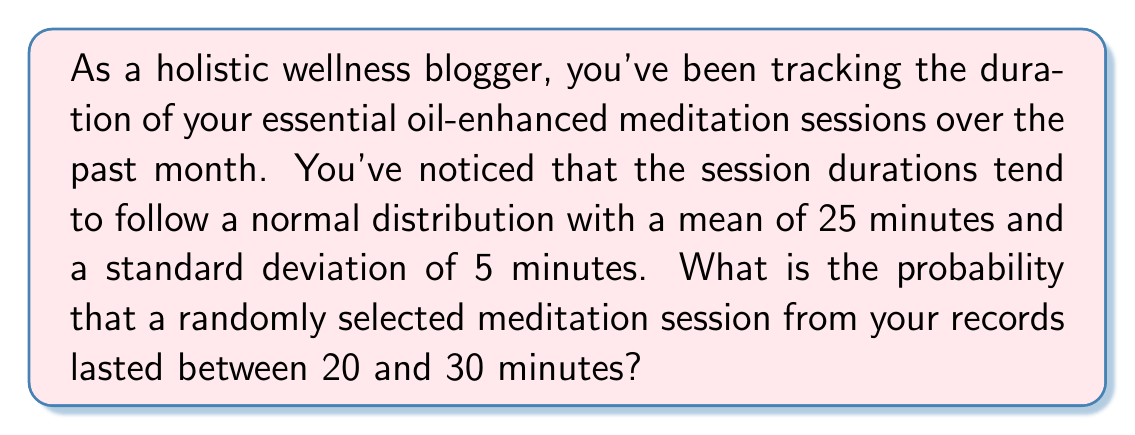Can you answer this question? To solve this problem, we'll use the properties of the normal distribution and the concept of z-scores.

1. Given information:
   - The meditation session durations follow a normal distribution
   - Mean (μ) = 25 minutes
   - Standard deviation (σ) = 5 minutes
   - We want to find P(20 < X < 30), where X is the duration of a session

2. Convert the duration limits to z-scores:
   For the lower limit: $z_1 = \frac{20 - 25}{5} = -1$
   For the upper limit: $z_2 = \frac{30 - 25}{5} = 1$

3. The problem now becomes finding P(-1 < Z < 1), where Z is the standard normal variable.

4. Using the standard normal distribution table or a calculator:
   P(Z < 1) = 0.8413
   P(Z < -1) = 0.1587

5. The probability we're looking for is:
   P(-1 < Z < 1) = P(Z < 1) - P(Z < -1)
                 = 0.8413 - 0.1587
                 = 0.6826

Therefore, the probability that a randomly selected meditation session lasted between 20 and 30 minutes is approximately 0.6826 or 68.26%.
Answer: 0.6826 or 68.26% 